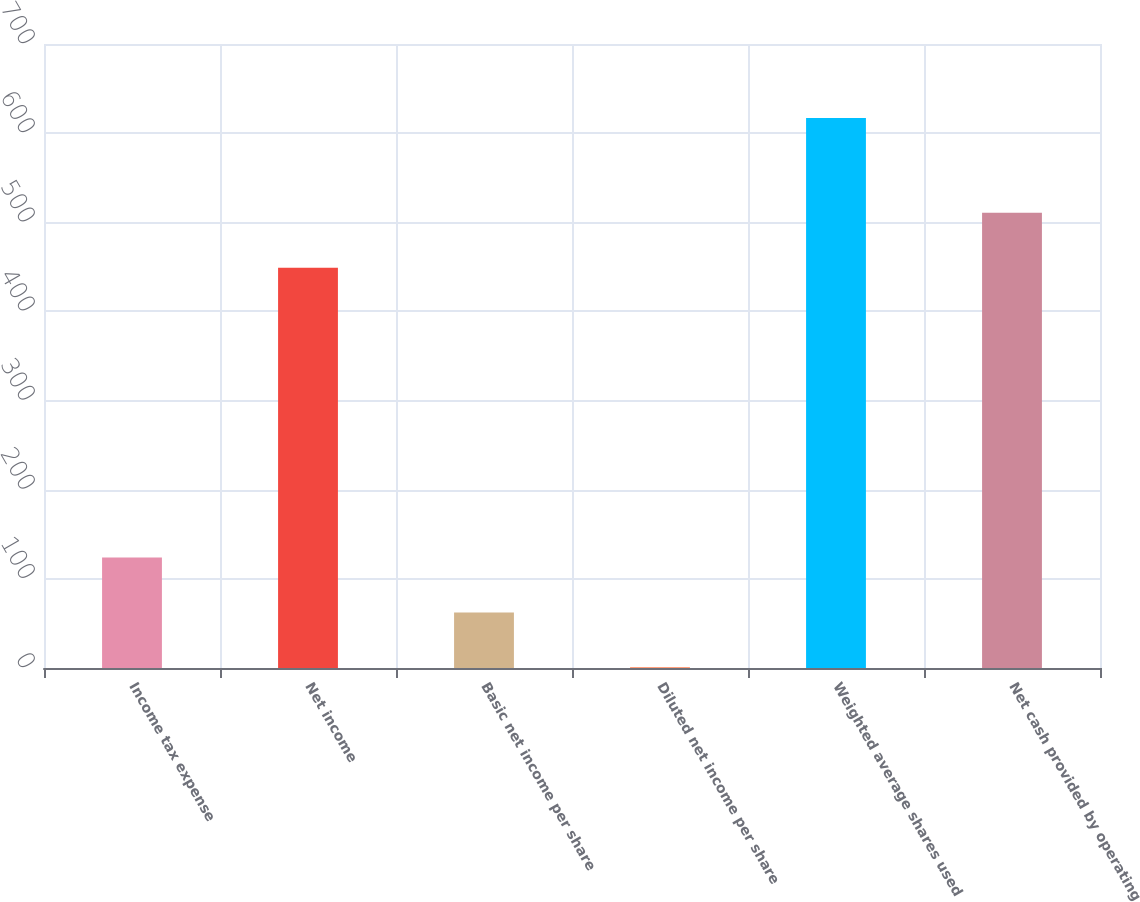<chart> <loc_0><loc_0><loc_500><loc_500><bar_chart><fcel>Income tax expense<fcel>Net income<fcel>Basic net income per share<fcel>Diluted net income per share<fcel>Weighted average shares used<fcel>Net cash provided by operating<nl><fcel>123.99<fcel>449<fcel>62.36<fcel>0.73<fcel>617<fcel>510.63<nl></chart> 